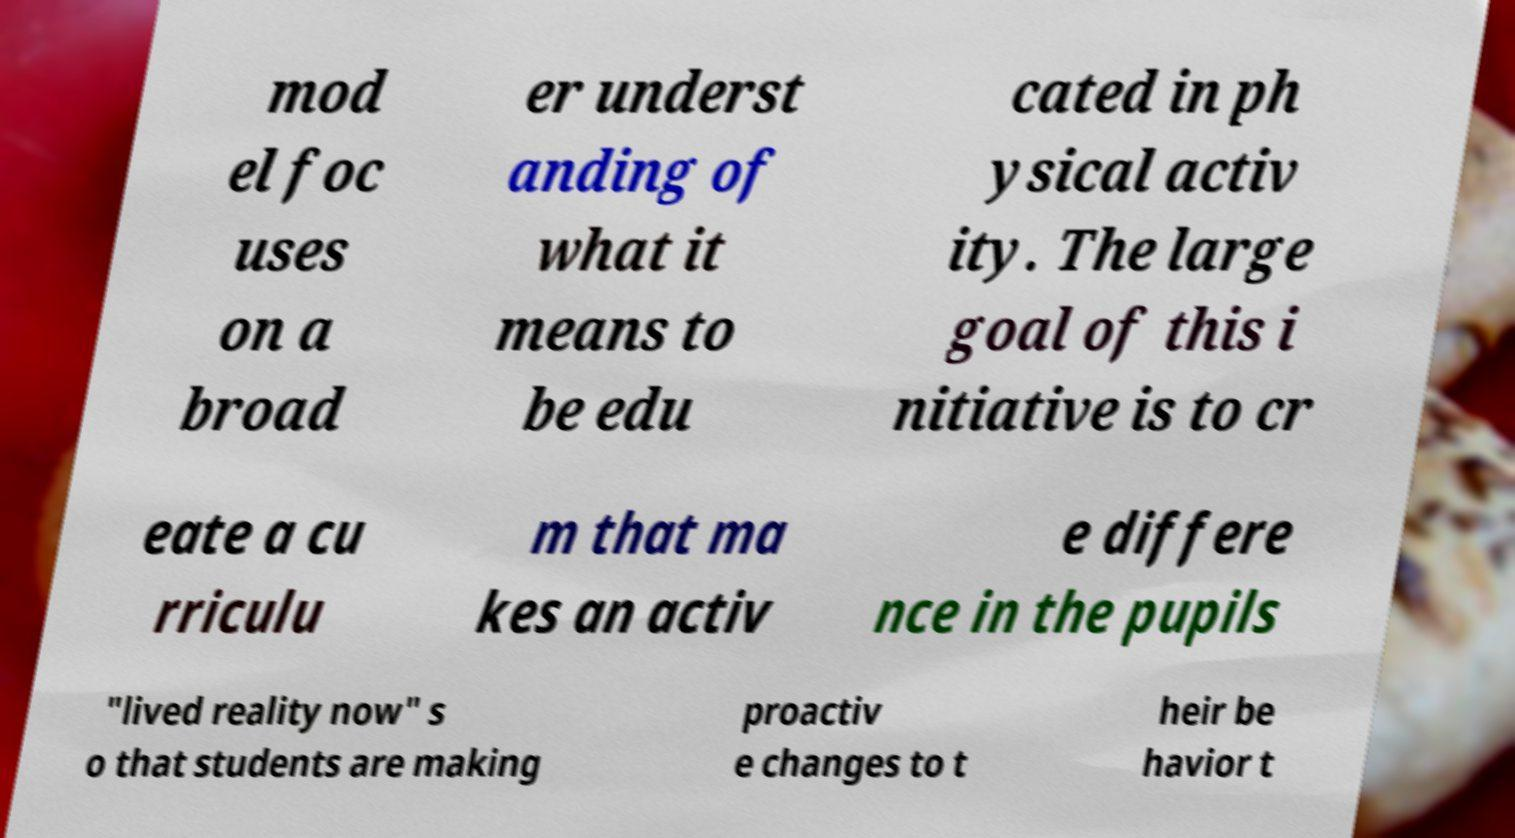Could you extract and type out the text from this image? mod el foc uses on a broad er underst anding of what it means to be edu cated in ph ysical activ ity. The large goal of this i nitiative is to cr eate a cu rriculu m that ma kes an activ e differe nce in the pupils "lived reality now" s o that students are making proactiv e changes to t heir be havior t 